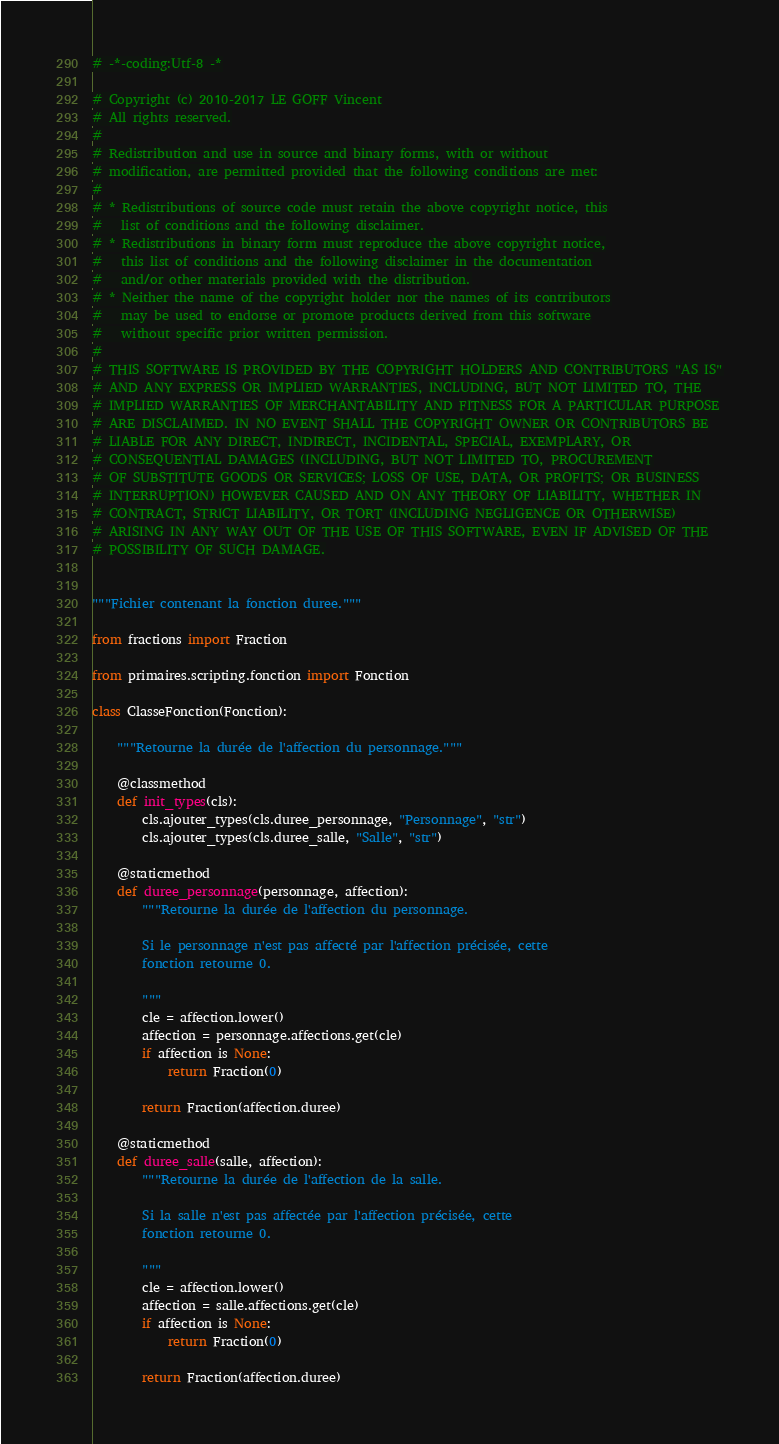Convert code to text. <code><loc_0><loc_0><loc_500><loc_500><_Python_># -*-coding:Utf-8 -*

# Copyright (c) 2010-2017 LE GOFF Vincent
# All rights reserved.
#
# Redistribution and use in source and binary forms, with or without
# modification, are permitted provided that the following conditions are met:
#
# * Redistributions of source code must retain the above copyright notice, this
#   list of conditions and the following disclaimer.
# * Redistributions in binary form must reproduce the above copyright notice,
#   this list of conditions and the following disclaimer in the documentation
#   and/or other materials provided with the distribution.
# * Neither the name of the copyright holder nor the names of its contributors
#   may be used to endorse or promote products derived from this software
#   without specific prior written permission.
#
# THIS SOFTWARE IS PROVIDED BY THE COPYRIGHT HOLDERS AND CONTRIBUTORS "AS IS"
# AND ANY EXPRESS OR IMPLIED WARRANTIES, INCLUDING, BUT NOT LIMITED TO, THE
# IMPLIED WARRANTIES OF MERCHANTABILITY AND FITNESS FOR A PARTICULAR PURPOSE
# ARE DISCLAIMED. IN NO EVENT SHALL THE COPYRIGHT OWNER OR CONTRIBUTORS BE
# LIABLE FOR ANY DIRECT, INDIRECT, INCIDENTAL, SPECIAL, EXEMPLARY, OR
# CONSEQUENTIAL DAMAGES (INCLUDING, BUT NOT LIMITED TO, PROCUREMENT
# OF SUBSTITUTE GOODS OR SERVICES; LOSS OF USE, DATA, OR PROFITS; OR BUSINESS
# INTERRUPTION) HOWEVER CAUSED AND ON ANY THEORY OF LIABILITY, WHETHER IN
# CONTRACT, STRICT LIABILITY, OR TORT (INCLUDING NEGLIGENCE OR OTHERWISE)
# ARISING IN ANY WAY OUT OF THE USE OF THIS SOFTWARE, EVEN IF ADVISED OF THE
# POSSIBILITY OF SUCH DAMAGE.


"""Fichier contenant la fonction duree."""

from fractions import Fraction

from primaires.scripting.fonction import Fonction

class ClasseFonction(Fonction):

    """Retourne la durée de l'affection du personnage."""

    @classmethod
    def init_types(cls):
        cls.ajouter_types(cls.duree_personnage, "Personnage", "str")
        cls.ajouter_types(cls.duree_salle, "Salle", "str")

    @staticmethod
    def duree_personnage(personnage, affection):
        """Retourne la durée de l'affection du personnage.

        Si le personnage n'est pas affecté par l'affection précisée, cette
        fonction retourne 0.

        """
        cle = affection.lower()
        affection = personnage.affections.get(cle)
        if affection is None:
            return Fraction(0)

        return Fraction(affection.duree)

    @staticmethod
    def duree_salle(salle, affection):
        """Retourne la durée de l'affection de la salle.

        Si la salle n'est pas affectée par l'affection précisée, cette
        fonction retourne 0.

        """
        cle = affection.lower()
        affection = salle.affections.get(cle)
        if affection is None:
            return Fraction(0)

        return Fraction(affection.duree)
</code> 